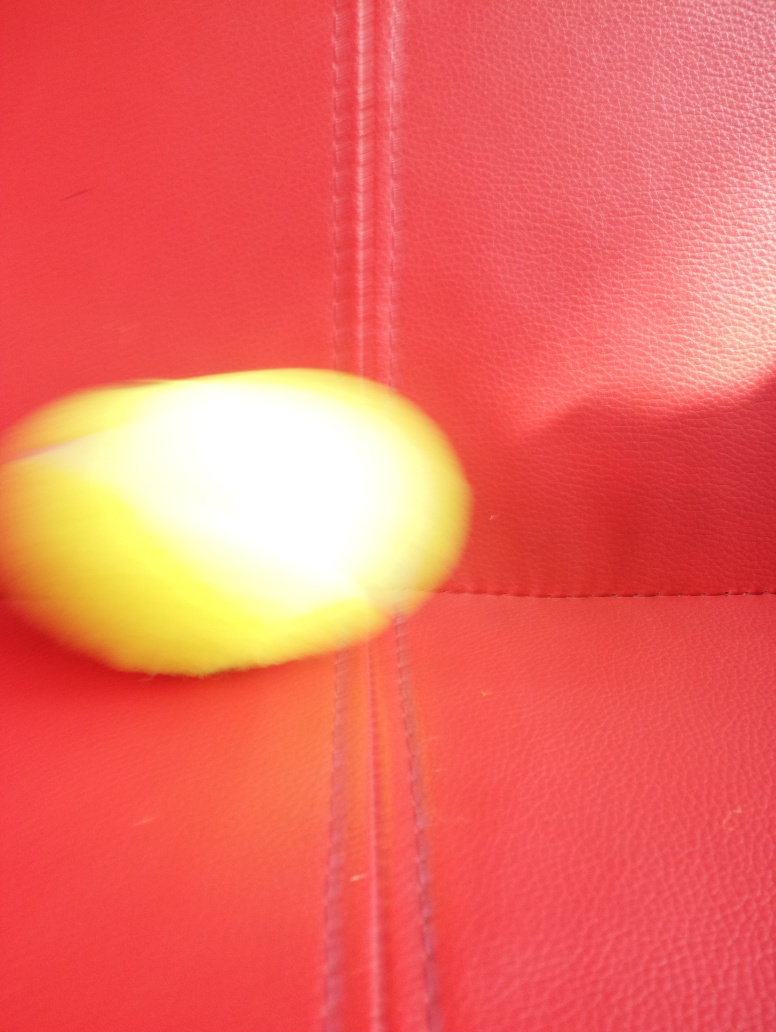Is there any indication of movement in the image? The blurred lines and the distortion of the yellow object do imply movement or a quick snapshot, possibly taken while the object was in motion or due to a shaky camera hand. 